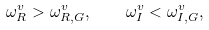<formula> <loc_0><loc_0><loc_500><loc_500>\omega ^ { v } _ { R } > \omega _ { R , G } ^ { v } , \quad \omega ^ { v } _ { I } < \omega _ { I , G } ^ { v } ,</formula> 